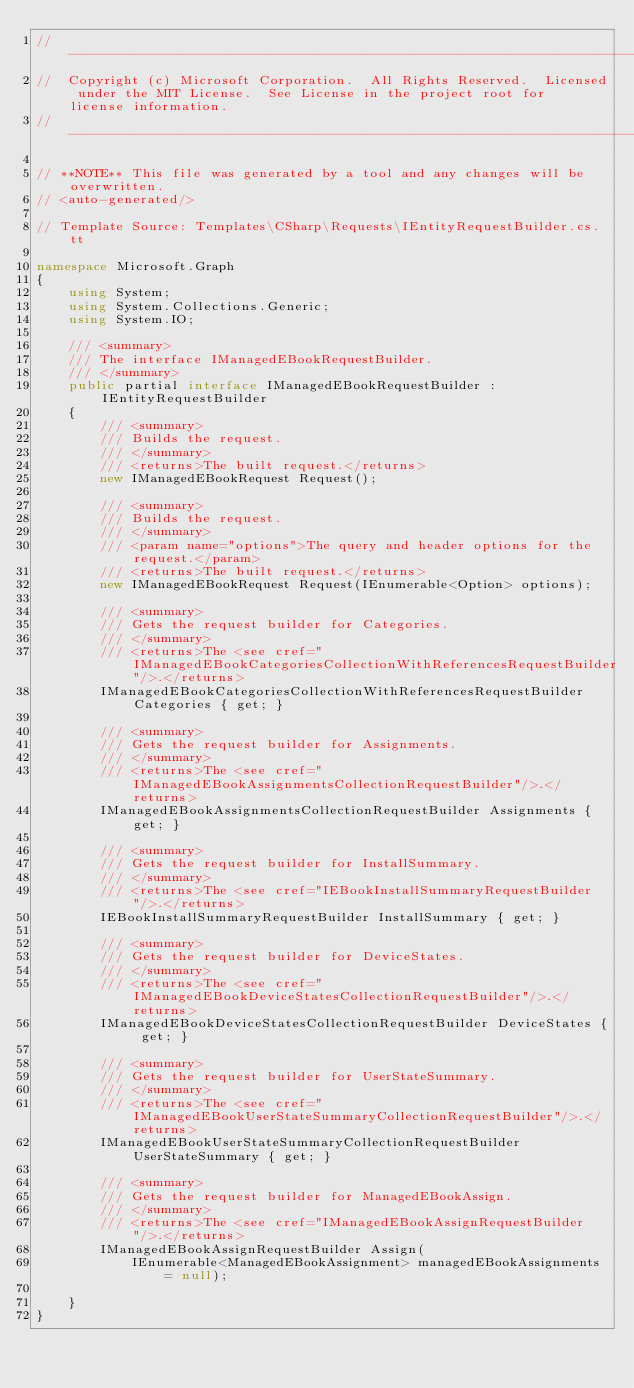<code> <loc_0><loc_0><loc_500><loc_500><_C#_>// ------------------------------------------------------------------------------
//  Copyright (c) Microsoft Corporation.  All Rights Reserved.  Licensed under the MIT License.  See License in the project root for license information.
// ------------------------------------------------------------------------------

// **NOTE** This file was generated by a tool and any changes will be overwritten.
// <auto-generated/>

// Template Source: Templates\CSharp\Requests\IEntityRequestBuilder.cs.tt

namespace Microsoft.Graph
{
    using System;
    using System.Collections.Generic;
    using System.IO;

    /// <summary>
    /// The interface IManagedEBookRequestBuilder.
    /// </summary>
    public partial interface IManagedEBookRequestBuilder : IEntityRequestBuilder
    {
        /// <summary>
        /// Builds the request.
        /// </summary>
        /// <returns>The built request.</returns>
        new IManagedEBookRequest Request();

        /// <summary>
        /// Builds the request.
        /// </summary>
        /// <param name="options">The query and header options for the request.</param>
        /// <returns>The built request.</returns>
        new IManagedEBookRequest Request(IEnumerable<Option> options);
    
        /// <summary>
        /// Gets the request builder for Categories.
        /// </summary>
        /// <returns>The <see cref="IManagedEBookCategoriesCollectionWithReferencesRequestBuilder"/>.</returns>
        IManagedEBookCategoriesCollectionWithReferencesRequestBuilder Categories { get; }

        /// <summary>
        /// Gets the request builder for Assignments.
        /// </summary>
        /// <returns>The <see cref="IManagedEBookAssignmentsCollectionRequestBuilder"/>.</returns>
        IManagedEBookAssignmentsCollectionRequestBuilder Assignments { get; }

        /// <summary>
        /// Gets the request builder for InstallSummary.
        /// </summary>
        /// <returns>The <see cref="IEBookInstallSummaryRequestBuilder"/>.</returns>
        IEBookInstallSummaryRequestBuilder InstallSummary { get; }

        /// <summary>
        /// Gets the request builder for DeviceStates.
        /// </summary>
        /// <returns>The <see cref="IManagedEBookDeviceStatesCollectionRequestBuilder"/>.</returns>
        IManagedEBookDeviceStatesCollectionRequestBuilder DeviceStates { get; }

        /// <summary>
        /// Gets the request builder for UserStateSummary.
        /// </summary>
        /// <returns>The <see cref="IManagedEBookUserStateSummaryCollectionRequestBuilder"/>.</returns>
        IManagedEBookUserStateSummaryCollectionRequestBuilder UserStateSummary { get; }
    
        /// <summary>
        /// Gets the request builder for ManagedEBookAssign.
        /// </summary>
        /// <returns>The <see cref="IManagedEBookAssignRequestBuilder"/>.</returns>
        IManagedEBookAssignRequestBuilder Assign(
            IEnumerable<ManagedEBookAssignment> managedEBookAssignments = null);
    
    }
}
</code> 